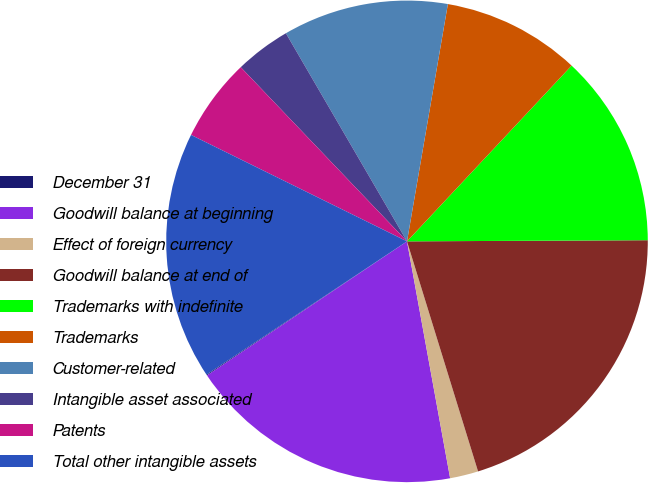Convert chart to OTSL. <chart><loc_0><loc_0><loc_500><loc_500><pie_chart><fcel>December 31<fcel>Goodwill balance at beginning<fcel>Effect of foreign currency<fcel>Goodwill balance at end of<fcel>Trademarks with indefinite<fcel>Trademarks<fcel>Customer-related<fcel>Intangible asset associated<fcel>Patents<fcel>Total other intangible assets<nl><fcel>0.06%<fcel>18.46%<fcel>1.9%<fcel>20.3%<fcel>12.94%<fcel>9.26%<fcel>11.1%<fcel>3.74%<fcel>5.58%<fcel>16.62%<nl></chart> 